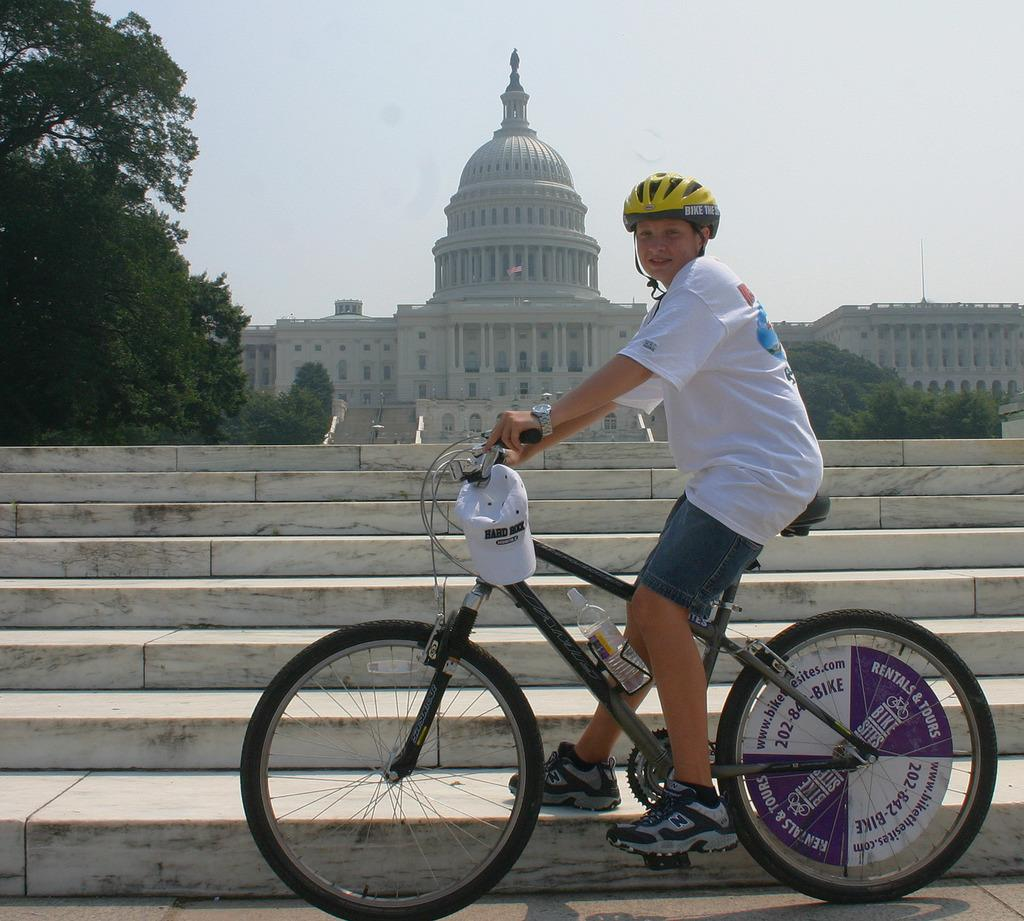What is the person in the image doing? There is a person sitting on a bicycle in the image. What can be seen in the background of the image? There are stairs, a building, trees, and the sky visible in the background of the image. What type of apparatus is being used to distribute yams in the image? There is no apparatus or yams present in the image. 